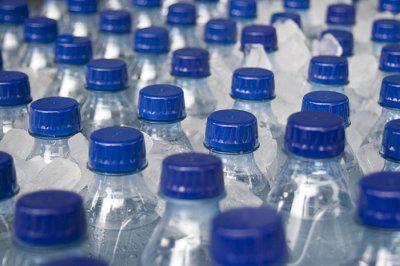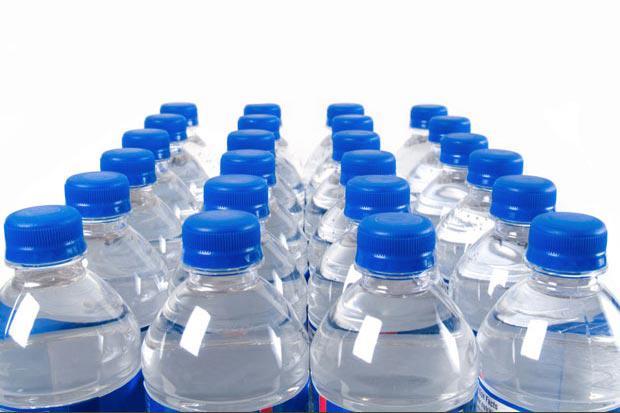The first image is the image on the left, the second image is the image on the right. Considering the images on both sides, is "In 1 of the images, the bottles have large rectangular reflections." valid? Answer yes or no. Yes. 